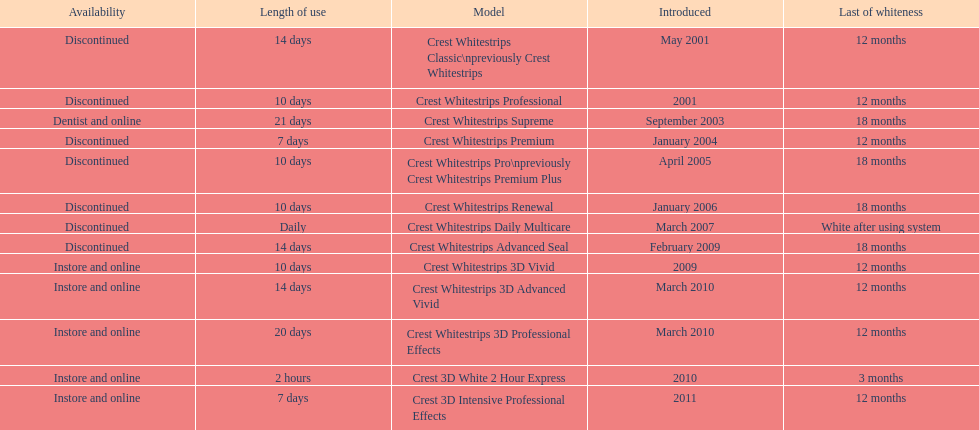Crest 3d intensive professional effects and crest whitestrips 3d professional effects both have a lasting whiteness of how many months? 12 months. 